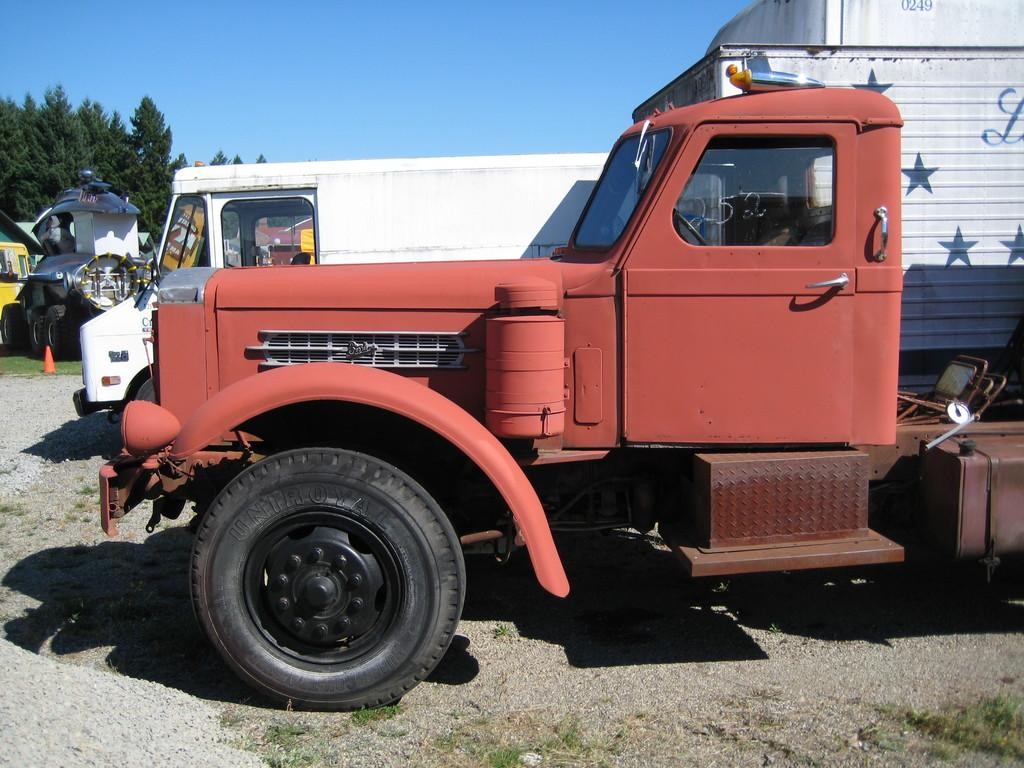What type of vehicles are in the image? There are trucks in the image. What type of vegetation can be seen in the image? There is grass visible in the image. What can be observed in the image that indicates the presence of light? There are shadows in the image. What safety device is present in the background of the image? There is an orange color cone in the background of the image. What type of natural scenery is visible in the background of the image? There are trees in the background of the image. What part of the natural environment is visible in the background of the image? The sky is visible in the background of the image. What type of magic is being performed by the trees in the image? There is no magic being performed by the trees in the image; they are simply trees in the background. 